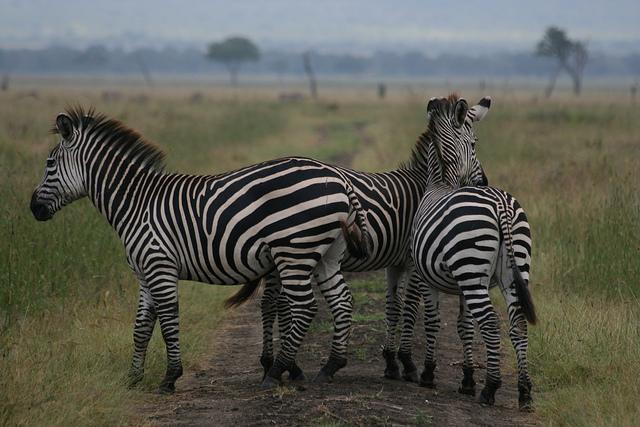How many zebras are standing in the way of the path?
Select the correct answer and articulate reasoning with the following format: 'Answer: answer
Rationale: rationale.'
Options: Two, three, four, one. Answer: three.
Rationale: There are 3. 